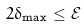Convert formula to latex. <formula><loc_0><loc_0><loc_500><loc_500>2 \delta _ { \max } \leq \mathcal { E }</formula> 